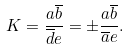Convert formula to latex. <formula><loc_0><loc_0><loc_500><loc_500>K = \frac { a \overline { b } } { \overline { d } e } = \pm \frac { a \overline { b } } { \overline { a } e } .</formula> 